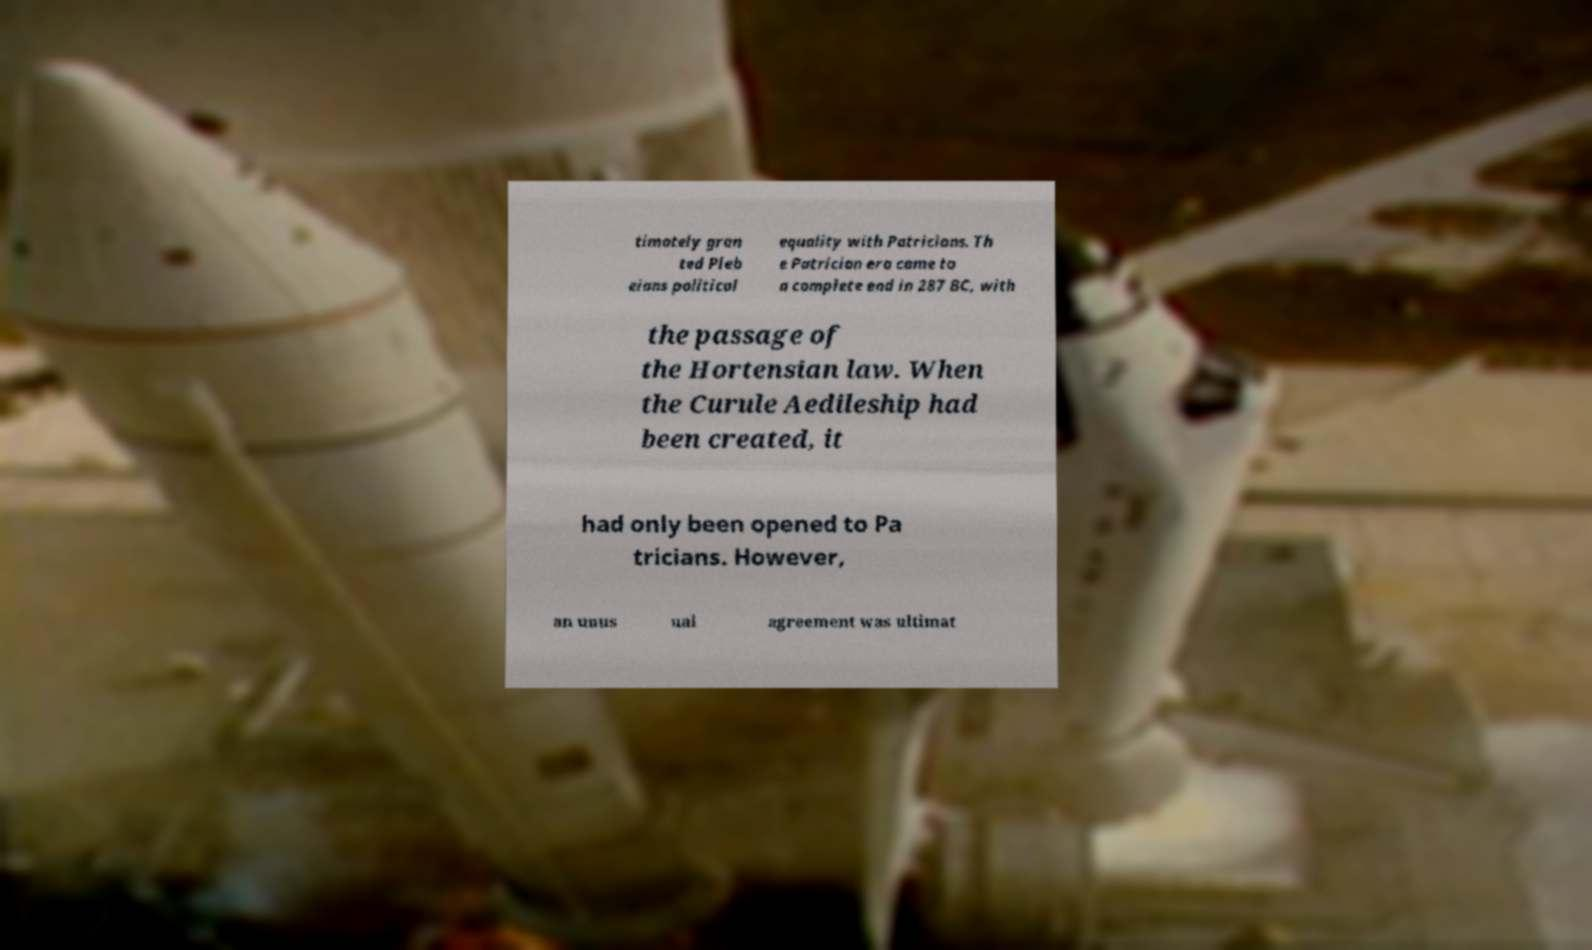Can you accurately transcribe the text from the provided image for me? timately gran ted Pleb eians political equality with Patricians. Th e Patrician era came to a complete end in 287 BC, with the passage of the Hortensian law. When the Curule Aedileship had been created, it had only been opened to Pa tricians. However, an unus ual agreement was ultimat 